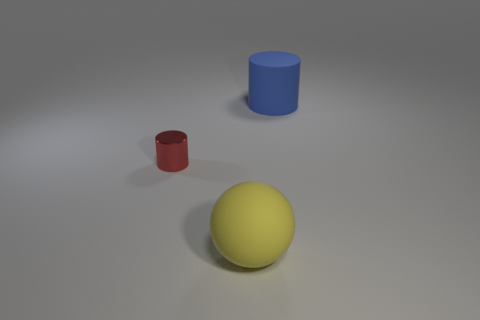Add 2 brown rubber cylinders. How many objects exist? 5 Subtract all spheres. How many objects are left? 2 Add 1 small shiny cylinders. How many small shiny cylinders are left? 2 Add 1 large purple cubes. How many large purple cubes exist? 1 Subtract 0 red balls. How many objects are left? 3 Subtract all big rubber spheres. Subtract all big yellow objects. How many objects are left? 1 